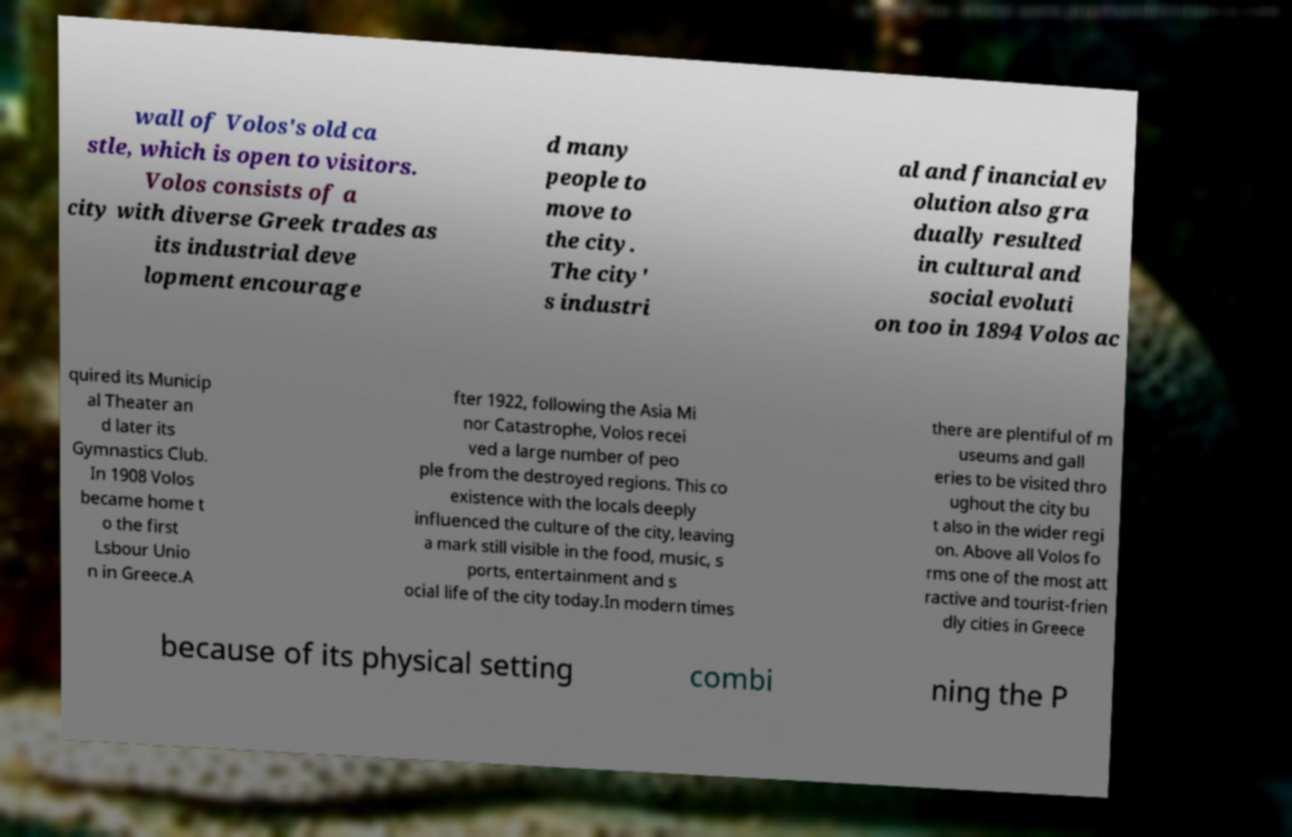Please read and relay the text visible in this image. What does it say? wall of Volos's old ca stle, which is open to visitors. Volos consists of a city with diverse Greek trades as its industrial deve lopment encourage d many people to move to the city. The city' s industri al and financial ev olution also gra dually resulted in cultural and social evoluti on too in 1894 Volos ac quired its Municip al Theater an d later its Gymnastics Club. In 1908 Volos became home t o the first Lsbour Unio n in Greece.A fter 1922, following the Asia Mi nor Catastrophe, Volos recei ved a large number of peo ple from the destroyed regions. This co existence with the locals deeply influenced the culture of the city, leaving a mark still visible in the food, music, s ports, entertainment and s ocial life of the city today.In modern times there are plentiful of m useums and gall eries to be visited thro ughout the city bu t also in the wider regi on. Above all Volos fo rms one of the most att ractive and tourist-frien dly cities in Greece because of its physical setting combi ning the P 